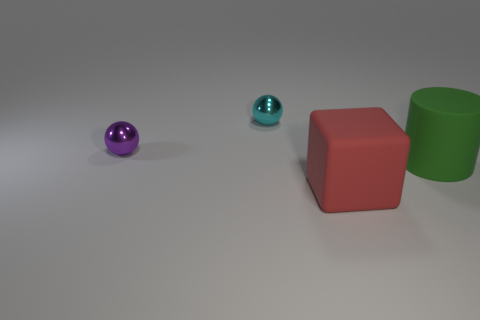Subtract 1 cylinders. How many cylinders are left? 0 Add 3 green matte spheres. How many objects exist? 7 Subtract 0 brown blocks. How many objects are left? 4 Subtract all cylinders. How many objects are left? 3 Subtract all cyan balls. Subtract all blue cylinders. How many balls are left? 1 Subtract all red rubber balls. Subtract all tiny purple objects. How many objects are left? 3 Add 1 large things. How many large things are left? 3 Add 3 tiny yellow metal cubes. How many tiny yellow metal cubes exist? 3 